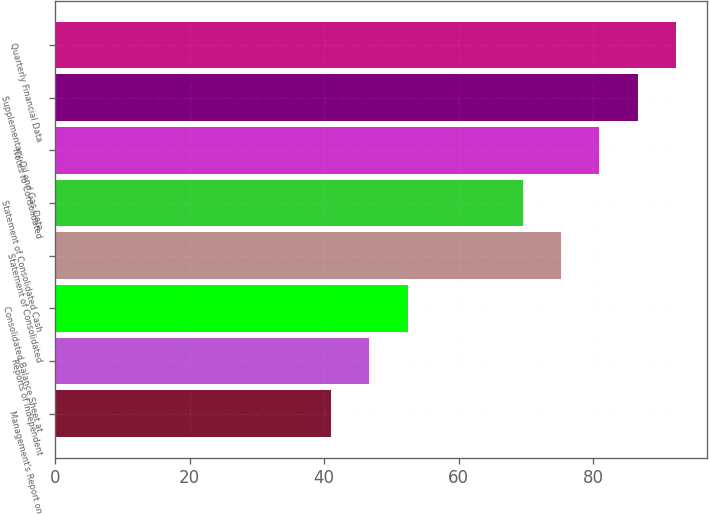Convert chart to OTSL. <chart><loc_0><loc_0><loc_500><loc_500><bar_chart><fcel>Management's Report on<fcel>Reports of Independent<fcel>Consolidated Balance Sheet at<fcel>Statement of Consolidated<fcel>Statement of Consolidated Cash<fcel>Notes to Consolidated<fcel>Supplementary Oil and Gas Data<fcel>Quarterly Financial Data<nl><fcel>41<fcel>46.7<fcel>52.4<fcel>75.2<fcel>69.5<fcel>80.9<fcel>86.6<fcel>92.3<nl></chart> 